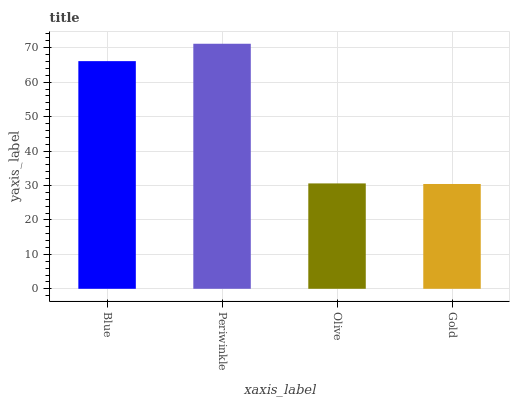Is Gold the minimum?
Answer yes or no. Yes. Is Periwinkle the maximum?
Answer yes or no. Yes. Is Olive the minimum?
Answer yes or no. No. Is Olive the maximum?
Answer yes or no. No. Is Periwinkle greater than Olive?
Answer yes or no. Yes. Is Olive less than Periwinkle?
Answer yes or no. Yes. Is Olive greater than Periwinkle?
Answer yes or no. No. Is Periwinkle less than Olive?
Answer yes or no. No. Is Blue the high median?
Answer yes or no. Yes. Is Olive the low median?
Answer yes or no. Yes. Is Olive the high median?
Answer yes or no. No. Is Periwinkle the low median?
Answer yes or no. No. 